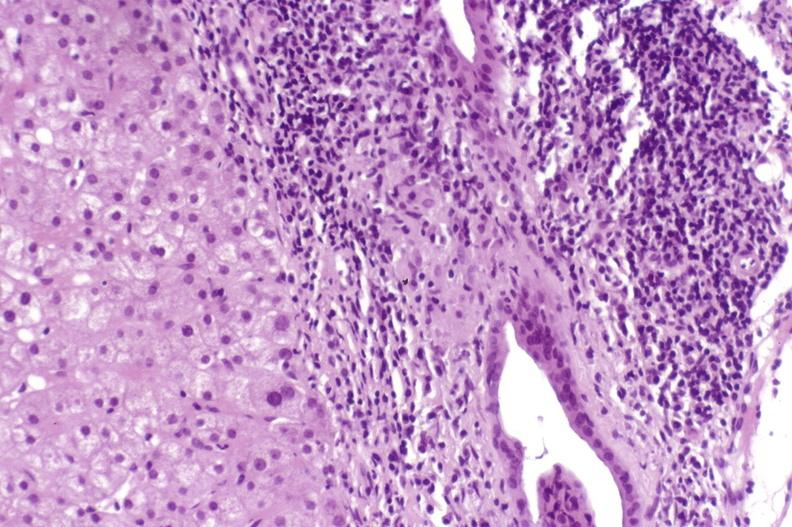s hand present?
Answer the question using a single word or phrase. No 